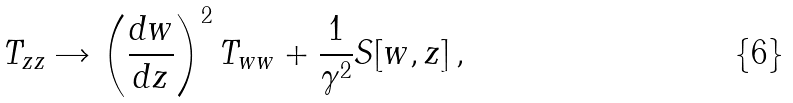<formula> <loc_0><loc_0><loc_500><loc_500>T _ { z z } \rightarrow \left ( \frac { d w } { d z } \right ) ^ { 2 } T _ { w w } + \frac { 1 } { \gamma ^ { 2 } } S [ w , z ] \, ,</formula> 